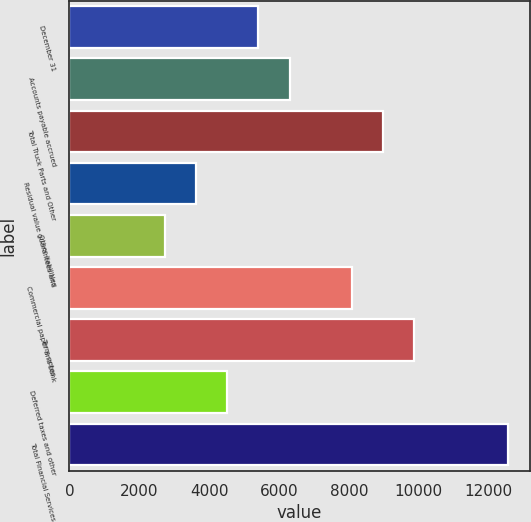Convert chart to OTSL. <chart><loc_0><loc_0><loc_500><loc_500><bar_chart><fcel>December 31<fcel>Accounts payable accrued<fcel>Total Truck Parts and Other<fcel>Residual value guarantees and<fcel>Other liabilities<fcel>Commercial paper and bank<fcel>Term notes<fcel>Deferred taxes and other<fcel>Total Financial Services<nl><fcel>5410.4<fcel>6302.7<fcel>8979.6<fcel>3625.8<fcel>2733.5<fcel>8087.3<fcel>9871.9<fcel>4518.1<fcel>12548.8<nl></chart> 